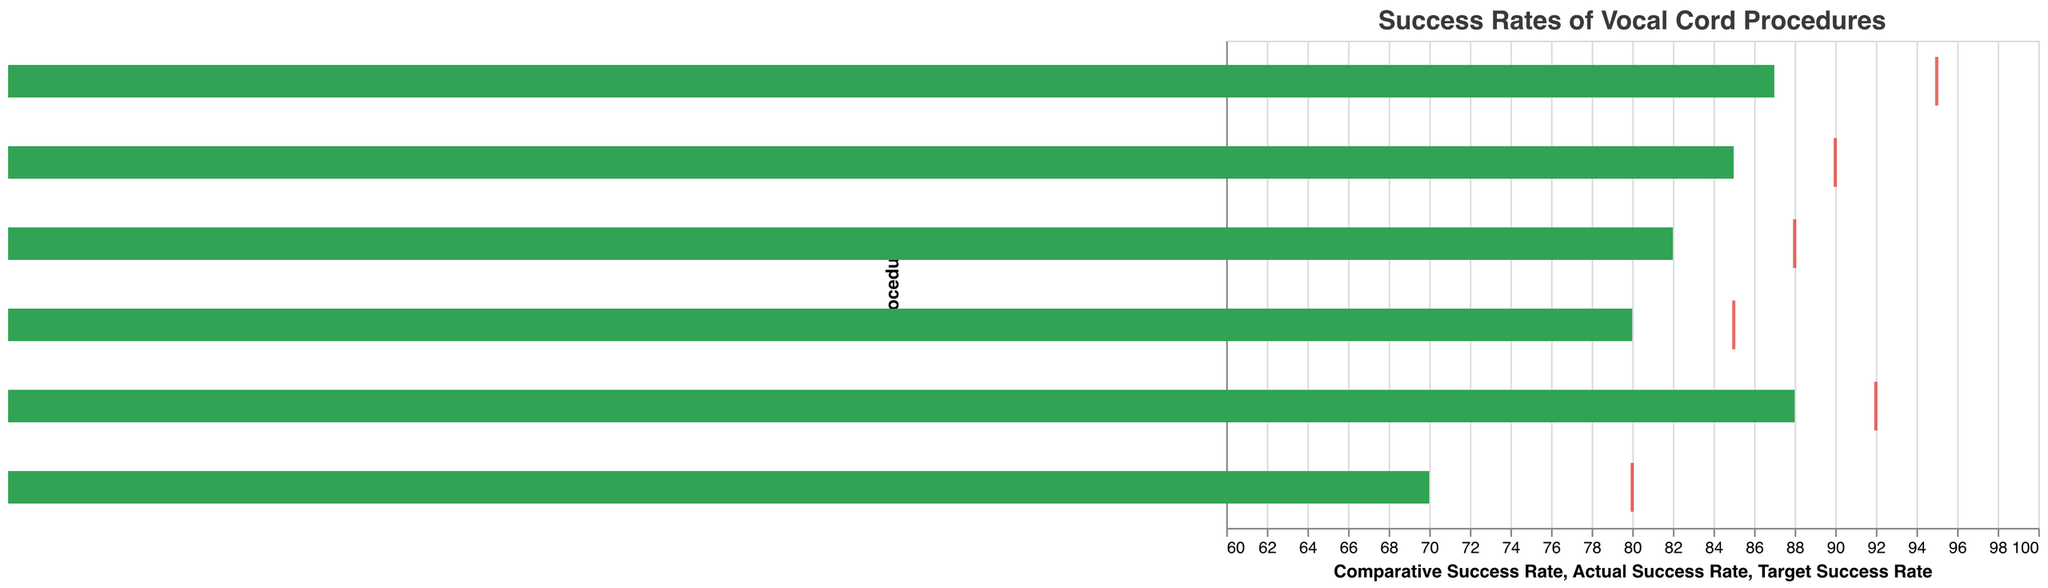What's the title of the figure? The title of the figure is typically at the top and it describes the content or the focus of the chart. In this case, it is provided in the `title` section of the code.
Answer: Success Rates of Vocal Cord Procedures What is the actual success rate for traditional open laryngeal surgery? To find this information, look for "Traditional Open Laryngeal Surgery" in the "Procedure" column and then refer to the "Actual Success Rate" column.
Answer: 70% Which procedure has the highest target success rate? Compare the "Target Success Rate" values for all procedures and find the maximum value. CO2 Laser Microsurgery has the highest target success rate.
Answer: CO2 Laser Microsurgery How much does the actual success rate of laser cordectomy fall short of the target success rate? Subtract the "Actual Success Rate" for Laser Cordectomy from the "Target Success Rate" for Laser Cordectomy: 90 - 85.
Answer: 5% What are the three procedures with the highest comparative success rates? Sort the procedures based on the "Comparative Success Rate" and identify the top three values. These are CO2 Laser Microsurgery (82%), Phonosurgery with Microflap Technique (80%), and Laser Cordectomy (78%).
Answer: CO2 Laser Microsurgery, Phonosurgery with Microflap Technique, Laser Cordectomy What's the difference between the comparative success rate and the actual success rate for microlaryngoscopy with cold instruments? Subtract the "Comparative Success Rate" from the "Actual Success Rate" for this procedure: 82 - 75.
Answer: 7% Which procedure shows the smallest gap between its actual success rate and target success rate? Calculate the differences between "Actual Success Rate" and "Target Success Rate" for all procedures. The smallest gap is for Office-Based Pulsed-KTP Laser Treatment, which is 5%.
Answer: Office-Based Pulsed-KTP Laser Treatment How do minimally invasive procedures compare to the traditional open laryngeal surgery in terms of actual success rates? Compare the "Actual Success Rate" of minimally invasive procedures (all except Traditional Open Laryngeal Surgery) with the "Actual Success Rate" of Traditional Open Laryngeal Surgery (70%).
Answer: All minimally invasive procedures have higher actual success rates than traditional open laryngeal surgery 